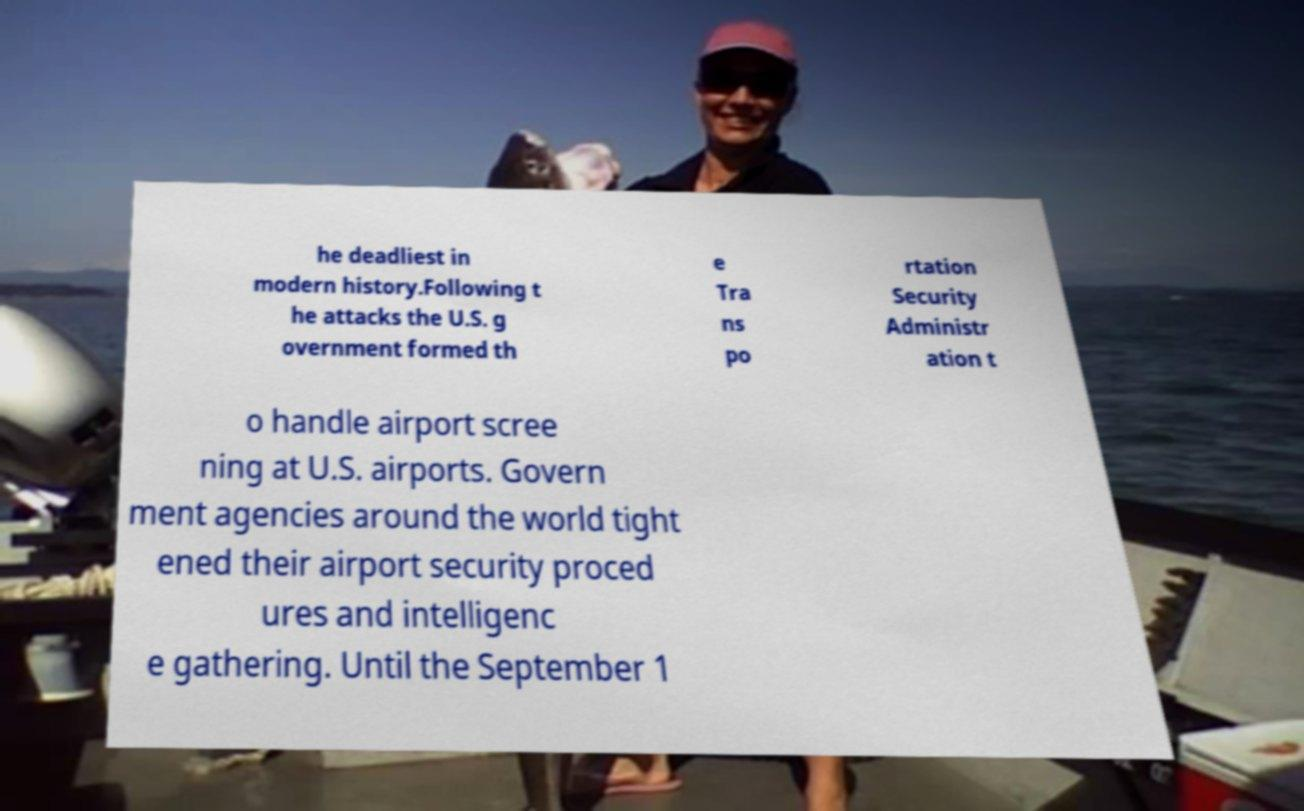For documentation purposes, I need the text within this image transcribed. Could you provide that? he deadliest in modern history.Following t he attacks the U.S. g overnment formed th e Tra ns po rtation Security Administr ation t o handle airport scree ning at U.S. airports. Govern ment agencies around the world tight ened their airport security proced ures and intelligenc e gathering. Until the September 1 